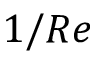<formula> <loc_0><loc_0><loc_500><loc_500>1 / R e</formula> 